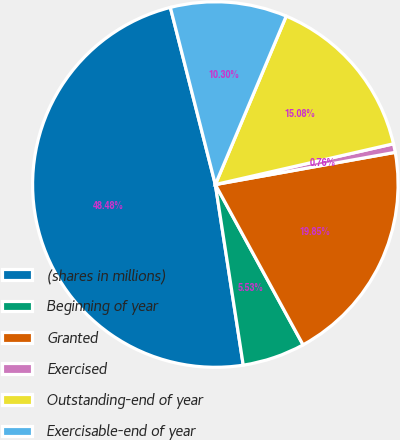Convert chart to OTSL. <chart><loc_0><loc_0><loc_500><loc_500><pie_chart><fcel>(shares in millions)<fcel>Beginning of year<fcel>Granted<fcel>Exercised<fcel>Outstanding-end of year<fcel>Exercisable-end of year<nl><fcel>48.48%<fcel>5.53%<fcel>19.85%<fcel>0.76%<fcel>15.08%<fcel>10.3%<nl></chart> 